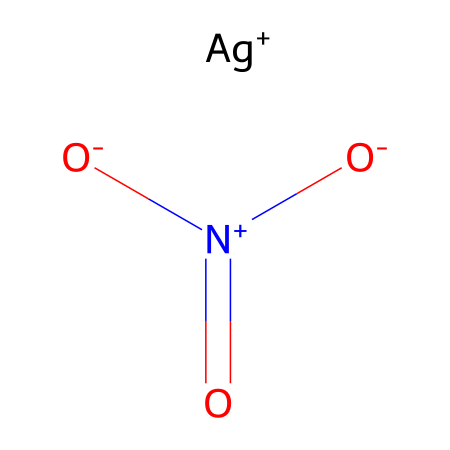What is the central atom in silver nitrate? The central atom can be identified as silver, which is represented by the 'Ag' in the SMILES notation. Other elements surrounding it are part of the nitrate group, but silver is the central atom.
Answer: silver How many oxygen atoms are present in silver nitrate? By analyzing the chemical structure from the SMILES representation, there are three oxygen atoms connected to the nitrogen atom in the nitrate group.
Answer: three What charge does the silver atom carry in this molecule? The SMILES notation shows "[Ag+]", indicating that the silver atom carries a positive charge.
Answer: positive Which part of the molecule acts as the oxidizing agent? The nitrate ion (NO3-) is known to be a strong oxidizing agent in chemical reactions, allowing it to oxidize other substances. In the structure, this is represented by the nitrogen and three oxygen atoms.
Answer: nitrate ion What type of reaction is silver nitrate commonly involved in during film development? Silver nitrate plays a key role in photographic processing, particularly in redox reactions where it is reduced to form metallic silver. This process is critical in developing photosensitive film.
Answer: redox reaction How many total bonds are present in the nitrate ion of silver nitrate? The nitrate ion has a nitrogen atom bonded to three oxygen atoms, with one of these bonds being a double bond, resulting in a total of four bonds.
Answer: four 